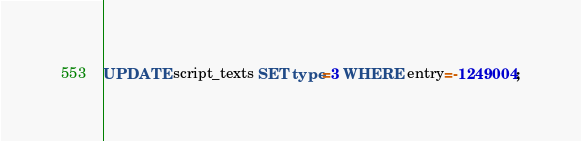<code> <loc_0><loc_0><loc_500><loc_500><_SQL_>UPDATE script_texts SET type=3 WHERE entry=-1249004;
</code> 